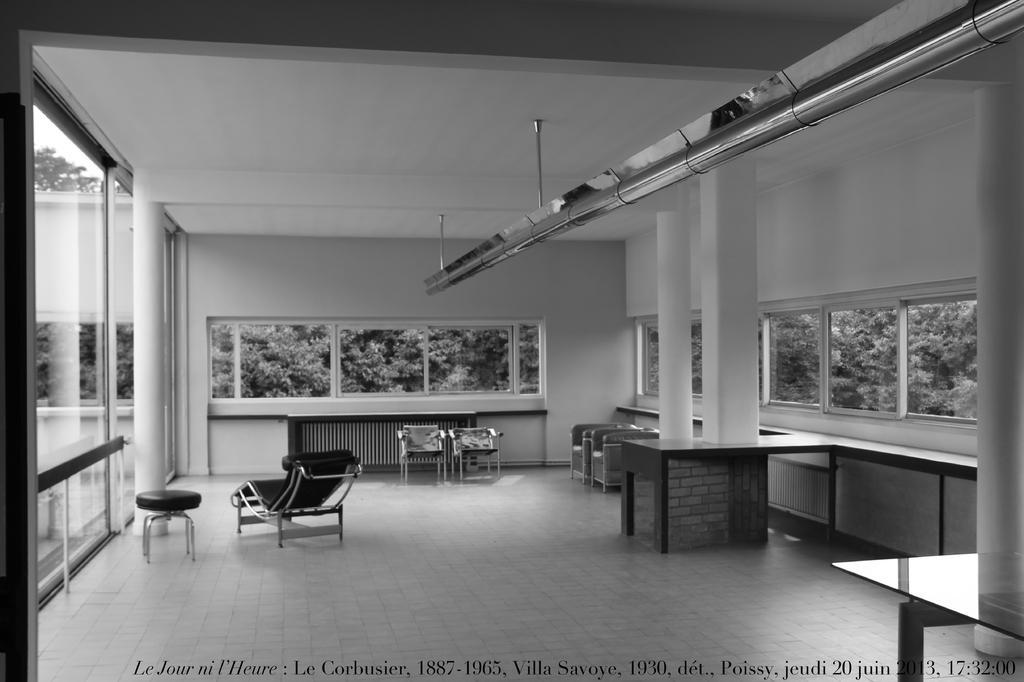Please provide a concise description of this image. In this image there are tables, chairs. There are glass windows through which we see the trees. On the left side of the image there is a glass door. There is a wall. On top of the image there is a metal rod. There is some text at the bottom of the image. 